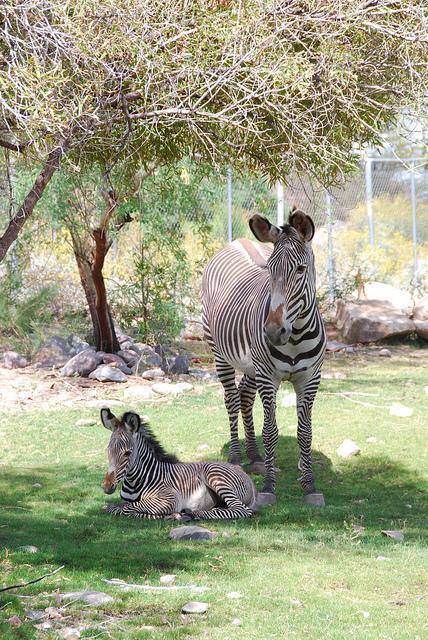How many zebras are there?
Give a very brief answer. 2. 